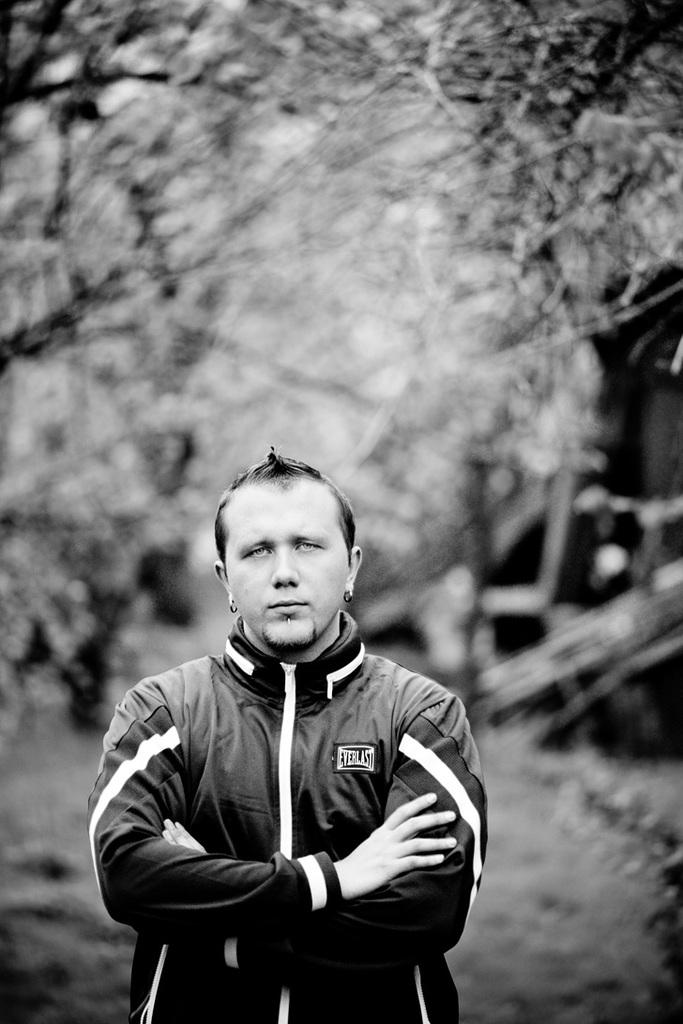What is the color scheme of the image? The image is black and white. Can you describe the main subject in the image? There is a person standing in the front of the image. What can be observed about the background of the person? The background of the person is blurred. How many friends are visible in the image? There are no friends visible in the image, as it only features a single person standing in the front. What message of peace can be seen in the image? There is no message of peace present in the image, as it is a simple black and white photograph of a person standing in the front with a blurred background. 